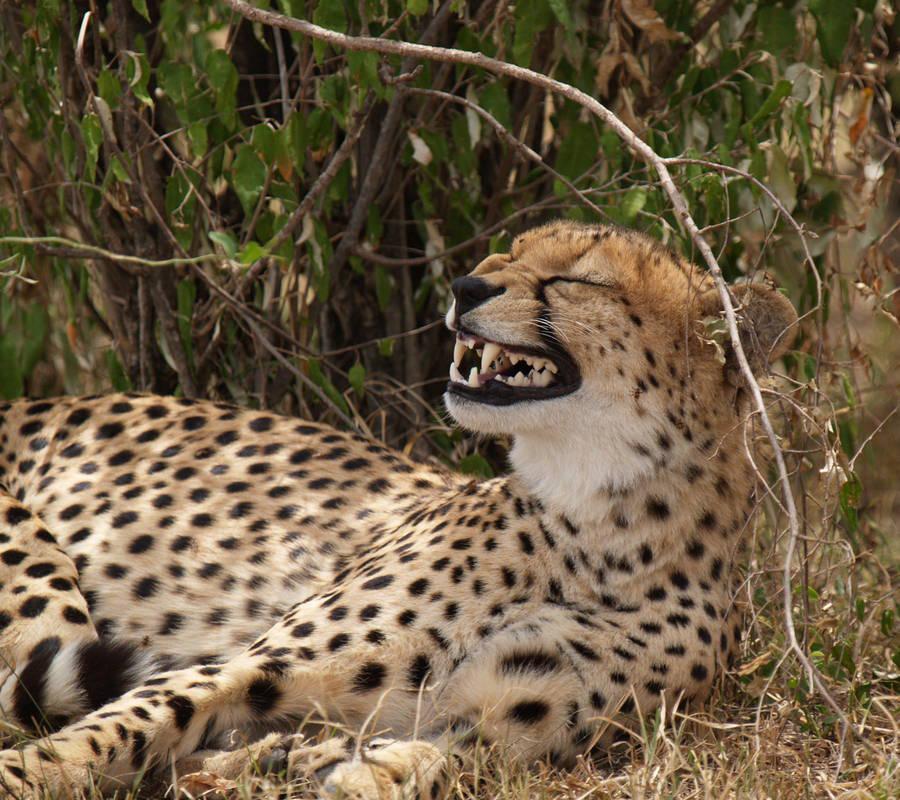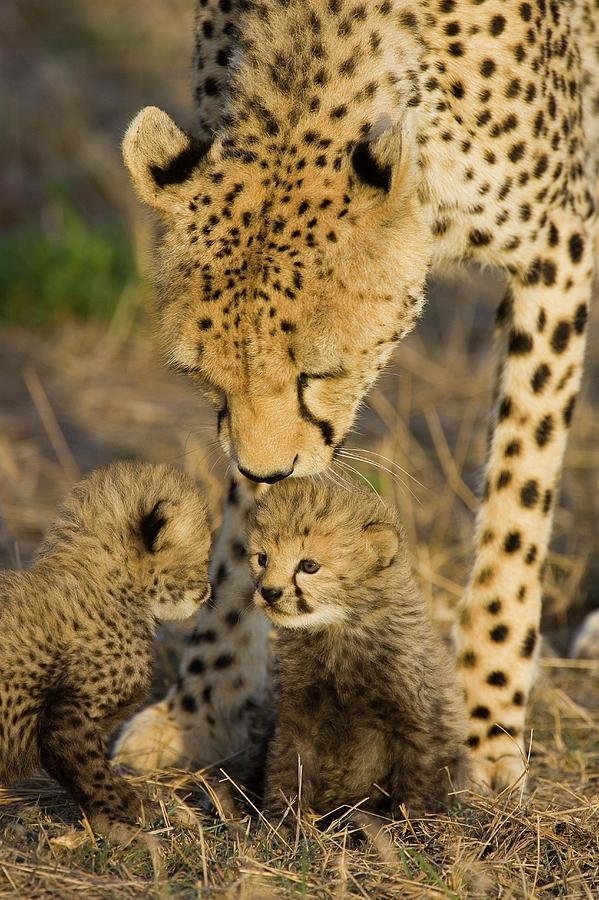The first image is the image on the left, the second image is the image on the right. Examine the images to the left and right. Is the description "A larger spotted wild cat is extending its neck and head toward the head of a smaller spotted wild cat." accurate? Answer yes or no. Yes. The first image is the image on the left, the second image is the image on the right. For the images shown, is this caption "The right image has at least two cheetahs." true? Answer yes or no. Yes. 